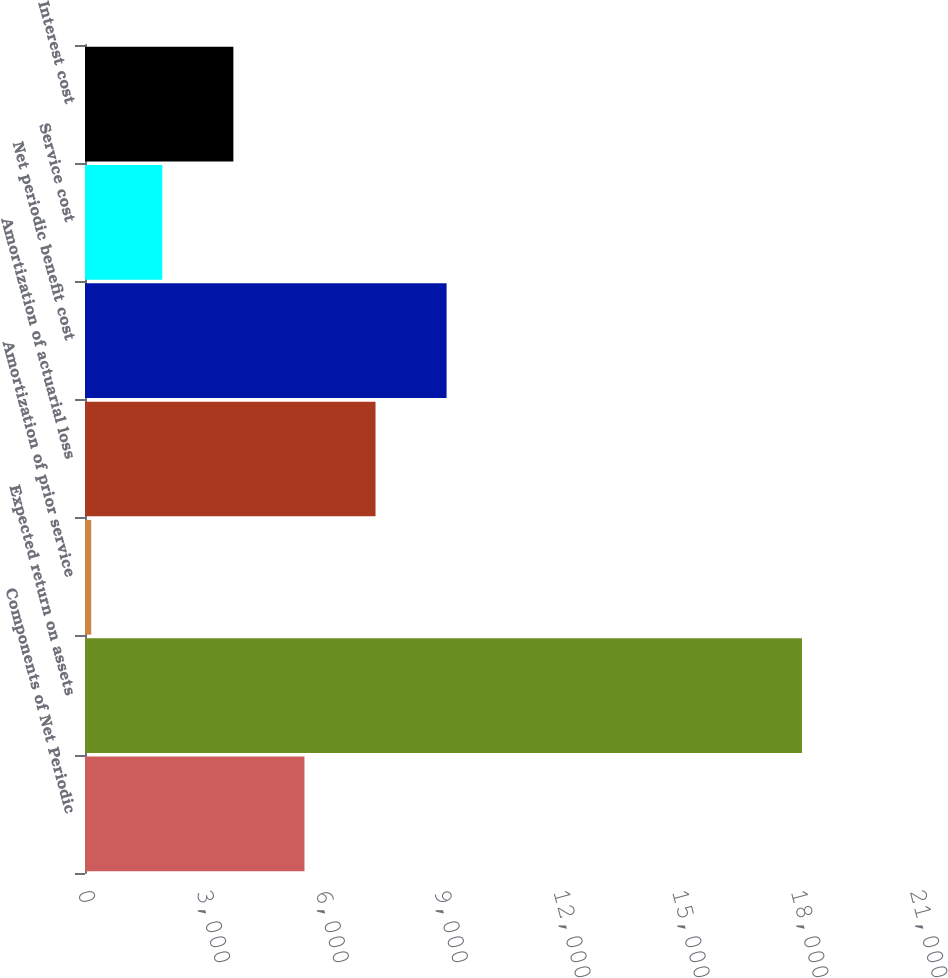Convert chart to OTSL. <chart><loc_0><loc_0><loc_500><loc_500><bar_chart><fcel>Components of Net Periodic<fcel>Expected return on assets<fcel>Amortization of prior service<fcel>Amortization of actuarial loss<fcel>Net periodic benefit cost<fcel>Service cost<fcel>Interest cost<nl><fcel>5539<fcel>18097<fcel>157<fcel>7333<fcel>9127<fcel>1951<fcel>3745<nl></chart> 